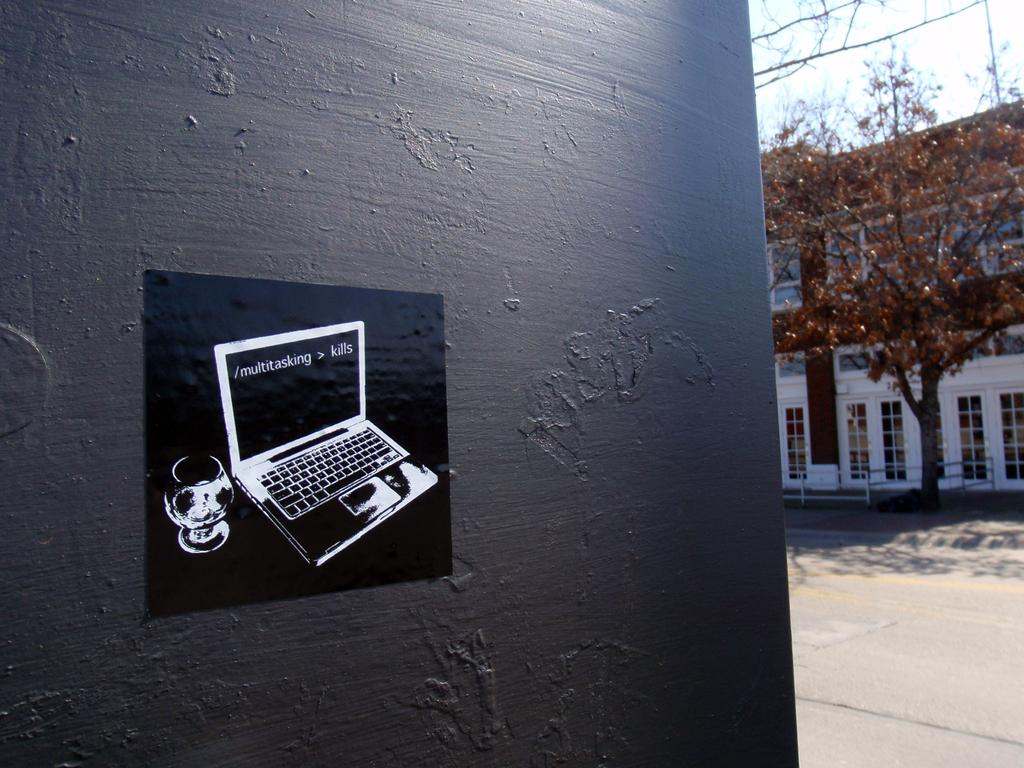Provide a one-sentence caption for the provided image. Sticker of a laptop on a wall that says multitasking on the screen. 